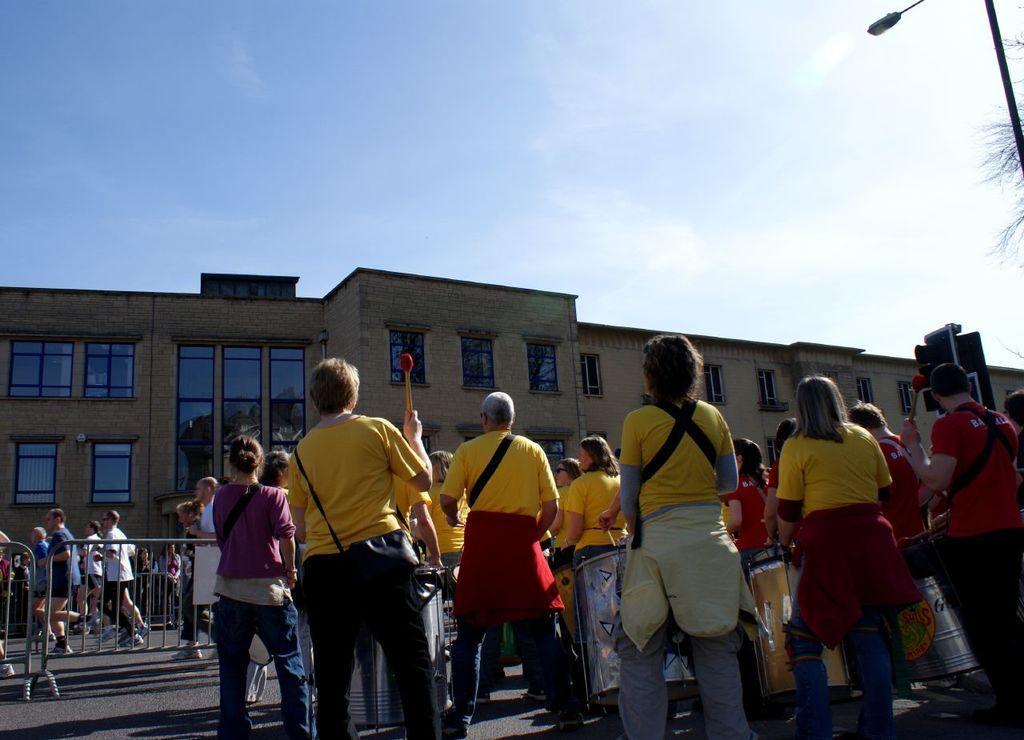Please provide a concise description of this image. In this image we can see people standing on the road, building with windows, fence, light pole and in the background we can see the sky. 